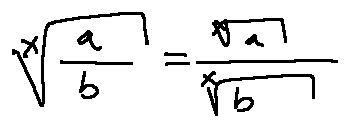Convert formula to latex. <formula><loc_0><loc_0><loc_500><loc_500>\sqrt { [ } x ] { \frac { a } { b } } = \frac { \sqrt { [ } x ] { a } } { \sqrt { [ } x ] { b } }</formula> 